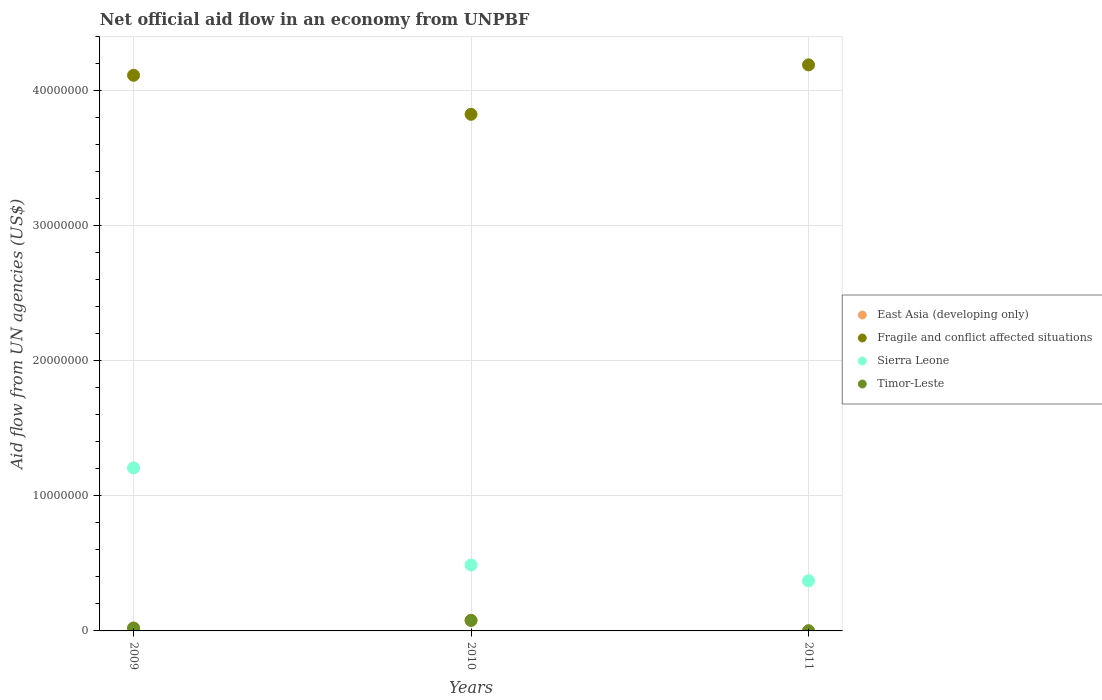How many different coloured dotlines are there?
Your answer should be compact. 4. Is the number of dotlines equal to the number of legend labels?
Give a very brief answer. Yes. What is the net official aid flow in Fragile and conflict affected situations in 2010?
Provide a short and direct response. 3.82e+07. Across all years, what is the maximum net official aid flow in Fragile and conflict affected situations?
Keep it short and to the point. 4.19e+07. Across all years, what is the minimum net official aid flow in Timor-Leste?
Offer a very short reply. 10000. In which year was the net official aid flow in East Asia (developing only) minimum?
Your answer should be compact. 2011. What is the total net official aid flow in Timor-Leste in the graph?
Keep it short and to the point. 1.00e+06. What is the difference between the net official aid flow in East Asia (developing only) in 2010 and that in 2011?
Give a very brief answer. 7.70e+05. What is the difference between the net official aid flow in East Asia (developing only) in 2011 and the net official aid flow in Sierra Leone in 2009?
Ensure brevity in your answer.  -1.21e+07. What is the average net official aid flow in Timor-Leste per year?
Ensure brevity in your answer.  3.33e+05. In the year 2011, what is the difference between the net official aid flow in Fragile and conflict affected situations and net official aid flow in East Asia (developing only)?
Offer a terse response. 4.19e+07. In how many years, is the net official aid flow in Fragile and conflict affected situations greater than 4000000 US$?
Offer a terse response. 3. Is the net official aid flow in Timor-Leste in 2009 less than that in 2011?
Offer a very short reply. No. What is the difference between the highest and the second highest net official aid flow in Sierra Leone?
Provide a short and direct response. 7.19e+06. What is the difference between the highest and the lowest net official aid flow in Sierra Leone?
Your answer should be compact. 8.36e+06. In how many years, is the net official aid flow in Fragile and conflict affected situations greater than the average net official aid flow in Fragile and conflict affected situations taken over all years?
Make the answer very short. 2. Is it the case that in every year, the sum of the net official aid flow in Timor-Leste and net official aid flow in Sierra Leone  is greater than the sum of net official aid flow in East Asia (developing only) and net official aid flow in Fragile and conflict affected situations?
Make the answer very short. Yes. Does the net official aid flow in Sierra Leone monotonically increase over the years?
Offer a very short reply. No. Is the net official aid flow in Timor-Leste strictly less than the net official aid flow in East Asia (developing only) over the years?
Provide a succinct answer. No. How many dotlines are there?
Make the answer very short. 4. How many years are there in the graph?
Provide a succinct answer. 3. Are the values on the major ticks of Y-axis written in scientific E-notation?
Your answer should be compact. No. Does the graph contain any zero values?
Give a very brief answer. No. Where does the legend appear in the graph?
Your response must be concise. Center right. What is the title of the graph?
Give a very brief answer. Net official aid flow in an economy from UNPBF. Does "Maldives" appear as one of the legend labels in the graph?
Provide a short and direct response. No. What is the label or title of the X-axis?
Give a very brief answer. Years. What is the label or title of the Y-axis?
Ensure brevity in your answer.  Aid flow from UN agencies (US$). What is the Aid flow from UN agencies (US$) of East Asia (developing only) in 2009?
Your answer should be very brief. 2.10e+05. What is the Aid flow from UN agencies (US$) of Fragile and conflict affected situations in 2009?
Give a very brief answer. 4.11e+07. What is the Aid flow from UN agencies (US$) of Sierra Leone in 2009?
Keep it short and to the point. 1.21e+07. What is the Aid flow from UN agencies (US$) of East Asia (developing only) in 2010?
Offer a terse response. 7.80e+05. What is the Aid flow from UN agencies (US$) in Fragile and conflict affected situations in 2010?
Provide a succinct answer. 3.82e+07. What is the Aid flow from UN agencies (US$) in Sierra Leone in 2010?
Offer a terse response. 4.88e+06. What is the Aid flow from UN agencies (US$) of Timor-Leste in 2010?
Offer a very short reply. 7.80e+05. What is the Aid flow from UN agencies (US$) in East Asia (developing only) in 2011?
Keep it short and to the point. 10000. What is the Aid flow from UN agencies (US$) in Fragile and conflict affected situations in 2011?
Offer a very short reply. 4.19e+07. What is the Aid flow from UN agencies (US$) in Sierra Leone in 2011?
Provide a short and direct response. 3.71e+06. Across all years, what is the maximum Aid flow from UN agencies (US$) in East Asia (developing only)?
Make the answer very short. 7.80e+05. Across all years, what is the maximum Aid flow from UN agencies (US$) in Fragile and conflict affected situations?
Provide a succinct answer. 4.19e+07. Across all years, what is the maximum Aid flow from UN agencies (US$) of Sierra Leone?
Ensure brevity in your answer.  1.21e+07. Across all years, what is the maximum Aid flow from UN agencies (US$) in Timor-Leste?
Make the answer very short. 7.80e+05. Across all years, what is the minimum Aid flow from UN agencies (US$) of Fragile and conflict affected situations?
Ensure brevity in your answer.  3.82e+07. Across all years, what is the minimum Aid flow from UN agencies (US$) of Sierra Leone?
Your response must be concise. 3.71e+06. Across all years, what is the minimum Aid flow from UN agencies (US$) of Timor-Leste?
Offer a very short reply. 10000. What is the total Aid flow from UN agencies (US$) of East Asia (developing only) in the graph?
Provide a succinct answer. 1.00e+06. What is the total Aid flow from UN agencies (US$) in Fragile and conflict affected situations in the graph?
Keep it short and to the point. 1.21e+08. What is the total Aid flow from UN agencies (US$) of Sierra Leone in the graph?
Ensure brevity in your answer.  2.07e+07. What is the total Aid flow from UN agencies (US$) of Timor-Leste in the graph?
Offer a terse response. 1.00e+06. What is the difference between the Aid flow from UN agencies (US$) of East Asia (developing only) in 2009 and that in 2010?
Give a very brief answer. -5.70e+05. What is the difference between the Aid flow from UN agencies (US$) in Fragile and conflict affected situations in 2009 and that in 2010?
Your answer should be very brief. 2.89e+06. What is the difference between the Aid flow from UN agencies (US$) of Sierra Leone in 2009 and that in 2010?
Your response must be concise. 7.19e+06. What is the difference between the Aid flow from UN agencies (US$) of Timor-Leste in 2009 and that in 2010?
Offer a terse response. -5.70e+05. What is the difference between the Aid flow from UN agencies (US$) in Fragile and conflict affected situations in 2009 and that in 2011?
Make the answer very short. -7.70e+05. What is the difference between the Aid flow from UN agencies (US$) in Sierra Leone in 2009 and that in 2011?
Ensure brevity in your answer.  8.36e+06. What is the difference between the Aid flow from UN agencies (US$) in Timor-Leste in 2009 and that in 2011?
Provide a short and direct response. 2.00e+05. What is the difference between the Aid flow from UN agencies (US$) in East Asia (developing only) in 2010 and that in 2011?
Make the answer very short. 7.70e+05. What is the difference between the Aid flow from UN agencies (US$) in Fragile and conflict affected situations in 2010 and that in 2011?
Give a very brief answer. -3.66e+06. What is the difference between the Aid flow from UN agencies (US$) of Sierra Leone in 2010 and that in 2011?
Your response must be concise. 1.17e+06. What is the difference between the Aid flow from UN agencies (US$) of Timor-Leste in 2010 and that in 2011?
Ensure brevity in your answer.  7.70e+05. What is the difference between the Aid flow from UN agencies (US$) of East Asia (developing only) in 2009 and the Aid flow from UN agencies (US$) of Fragile and conflict affected situations in 2010?
Your answer should be compact. -3.80e+07. What is the difference between the Aid flow from UN agencies (US$) of East Asia (developing only) in 2009 and the Aid flow from UN agencies (US$) of Sierra Leone in 2010?
Your answer should be compact. -4.67e+06. What is the difference between the Aid flow from UN agencies (US$) in East Asia (developing only) in 2009 and the Aid flow from UN agencies (US$) in Timor-Leste in 2010?
Give a very brief answer. -5.70e+05. What is the difference between the Aid flow from UN agencies (US$) of Fragile and conflict affected situations in 2009 and the Aid flow from UN agencies (US$) of Sierra Leone in 2010?
Offer a very short reply. 3.63e+07. What is the difference between the Aid flow from UN agencies (US$) in Fragile and conflict affected situations in 2009 and the Aid flow from UN agencies (US$) in Timor-Leste in 2010?
Provide a succinct answer. 4.04e+07. What is the difference between the Aid flow from UN agencies (US$) of Sierra Leone in 2009 and the Aid flow from UN agencies (US$) of Timor-Leste in 2010?
Keep it short and to the point. 1.13e+07. What is the difference between the Aid flow from UN agencies (US$) in East Asia (developing only) in 2009 and the Aid flow from UN agencies (US$) in Fragile and conflict affected situations in 2011?
Offer a very short reply. -4.17e+07. What is the difference between the Aid flow from UN agencies (US$) of East Asia (developing only) in 2009 and the Aid flow from UN agencies (US$) of Sierra Leone in 2011?
Make the answer very short. -3.50e+06. What is the difference between the Aid flow from UN agencies (US$) in Fragile and conflict affected situations in 2009 and the Aid flow from UN agencies (US$) in Sierra Leone in 2011?
Give a very brief answer. 3.74e+07. What is the difference between the Aid flow from UN agencies (US$) in Fragile and conflict affected situations in 2009 and the Aid flow from UN agencies (US$) in Timor-Leste in 2011?
Provide a short and direct response. 4.11e+07. What is the difference between the Aid flow from UN agencies (US$) of Sierra Leone in 2009 and the Aid flow from UN agencies (US$) of Timor-Leste in 2011?
Your answer should be very brief. 1.21e+07. What is the difference between the Aid flow from UN agencies (US$) in East Asia (developing only) in 2010 and the Aid flow from UN agencies (US$) in Fragile and conflict affected situations in 2011?
Provide a short and direct response. -4.11e+07. What is the difference between the Aid flow from UN agencies (US$) in East Asia (developing only) in 2010 and the Aid flow from UN agencies (US$) in Sierra Leone in 2011?
Your answer should be very brief. -2.93e+06. What is the difference between the Aid flow from UN agencies (US$) in East Asia (developing only) in 2010 and the Aid flow from UN agencies (US$) in Timor-Leste in 2011?
Provide a short and direct response. 7.70e+05. What is the difference between the Aid flow from UN agencies (US$) in Fragile and conflict affected situations in 2010 and the Aid flow from UN agencies (US$) in Sierra Leone in 2011?
Your answer should be compact. 3.45e+07. What is the difference between the Aid flow from UN agencies (US$) in Fragile and conflict affected situations in 2010 and the Aid flow from UN agencies (US$) in Timor-Leste in 2011?
Ensure brevity in your answer.  3.82e+07. What is the difference between the Aid flow from UN agencies (US$) in Sierra Leone in 2010 and the Aid flow from UN agencies (US$) in Timor-Leste in 2011?
Give a very brief answer. 4.87e+06. What is the average Aid flow from UN agencies (US$) of East Asia (developing only) per year?
Offer a terse response. 3.33e+05. What is the average Aid flow from UN agencies (US$) of Fragile and conflict affected situations per year?
Provide a short and direct response. 4.04e+07. What is the average Aid flow from UN agencies (US$) in Sierra Leone per year?
Keep it short and to the point. 6.89e+06. What is the average Aid flow from UN agencies (US$) of Timor-Leste per year?
Your answer should be compact. 3.33e+05. In the year 2009, what is the difference between the Aid flow from UN agencies (US$) in East Asia (developing only) and Aid flow from UN agencies (US$) in Fragile and conflict affected situations?
Ensure brevity in your answer.  -4.09e+07. In the year 2009, what is the difference between the Aid flow from UN agencies (US$) in East Asia (developing only) and Aid flow from UN agencies (US$) in Sierra Leone?
Your answer should be very brief. -1.19e+07. In the year 2009, what is the difference between the Aid flow from UN agencies (US$) of Fragile and conflict affected situations and Aid flow from UN agencies (US$) of Sierra Leone?
Your answer should be compact. 2.91e+07. In the year 2009, what is the difference between the Aid flow from UN agencies (US$) in Fragile and conflict affected situations and Aid flow from UN agencies (US$) in Timor-Leste?
Provide a short and direct response. 4.09e+07. In the year 2009, what is the difference between the Aid flow from UN agencies (US$) in Sierra Leone and Aid flow from UN agencies (US$) in Timor-Leste?
Provide a short and direct response. 1.19e+07. In the year 2010, what is the difference between the Aid flow from UN agencies (US$) of East Asia (developing only) and Aid flow from UN agencies (US$) of Fragile and conflict affected situations?
Offer a very short reply. -3.75e+07. In the year 2010, what is the difference between the Aid flow from UN agencies (US$) of East Asia (developing only) and Aid flow from UN agencies (US$) of Sierra Leone?
Your response must be concise. -4.10e+06. In the year 2010, what is the difference between the Aid flow from UN agencies (US$) in Fragile and conflict affected situations and Aid flow from UN agencies (US$) in Sierra Leone?
Your answer should be very brief. 3.34e+07. In the year 2010, what is the difference between the Aid flow from UN agencies (US$) of Fragile and conflict affected situations and Aid flow from UN agencies (US$) of Timor-Leste?
Ensure brevity in your answer.  3.75e+07. In the year 2010, what is the difference between the Aid flow from UN agencies (US$) in Sierra Leone and Aid flow from UN agencies (US$) in Timor-Leste?
Offer a terse response. 4.10e+06. In the year 2011, what is the difference between the Aid flow from UN agencies (US$) in East Asia (developing only) and Aid flow from UN agencies (US$) in Fragile and conflict affected situations?
Give a very brief answer. -4.19e+07. In the year 2011, what is the difference between the Aid flow from UN agencies (US$) in East Asia (developing only) and Aid flow from UN agencies (US$) in Sierra Leone?
Offer a very short reply. -3.70e+06. In the year 2011, what is the difference between the Aid flow from UN agencies (US$) in Fragile and conflict affected situations and Aid flow from UN agencies (US$) in Sierra Leone?
Give a very brief answer. 3.82e+07. In the year 2011, what is the difference between the Aid flow from UN agencies (US$) in Fragile and conflict affected situations and Aid flow from UN agencies (US$) in Timor-Leste?
Provide a succinct answer. 4.19e+07. In the year 2011, what is the difference between the Aid flow from UN agencies (US$) in Sierra Leone and Aid flow from UN agencies (US$) in Timor-Leste?
Your answer should be compact. 3.70e+06. What is the ratio of the Aid flow from UN agencies (US$) of East Asia (developing only) in 2009 to that in 2010?
Keep it short and to the point. 0.27. What is the ratio of the Aid flow from UN agencies (US$) of Fragile and conflict affected situations in 2009 to that in 2010?
Make the answer very short. 1.08. What is the ratio of the Aid flow from UN agencies (US$) in Sierra Leone in 2009 to that in 2010?
Give a very brief answer. 2.47. What is the ratio of the Aid flow from UN agencies (US$) in Timor-Leste in 2009 to that in 2010?
Make the answer very short. 0.27. What is the ratio of the Aid flow from UN agencies (US$) of Fragile and conflict affected situations in 2009 to that in 2011?
Your answer should be compact. 0.98. What is the ratio of the Aid flow from UN agencies (US$) in Sierra Leone in 2009 to that in 2011?
Give a very brief answer. 3.25. What is the ratio of the Aid flow from UN agencies (US$) of East Asia (developing only) in 2010 to that in 2011?
Provide a short and direct response. 78. What is the ratio of the Aid flow from UN agencies (US$) of Fragile and conflict affected situations in 2010 to that in 2011?
Your answer should be very brief. 0.91. What is the ratio of the Aid flow from UN agencies (US$) of Sierra Leone in 2010 to that in 2011?
Ensure brevity in your answer.  1.32. What is the difference between the highest and the second highest Aid flow from UN agencies (US$) in East Asia (developing only)?
Ensure brevity in your answer.  5.70e+05. What is the difference between the highest and the second highest Aid flow from UN agencies (US$) in Fragile and conflict affected situations?
Offer a very short reply. 7.70e+05. What is the difference between the highest and the second highest Aid flow from UN agencies (US$) of Sierra Leone?
Offer a terse response. 7.19e+06. What is the difference between the highest and the second highest Aid flow from UN agencies (US$) in Timor-Leste?
Ensure brevity in your answer.  5.70e+05. What is the difference between the highest and the lowest Aid flow from UN agencies (US$) in East Asia (developing only)?
Your answer should be very brief. 7.70e+05. What is the difference between the highest and the lowest Aid flow from UN agencies (US$) of Fragile and conflict affected situations?
Offer a terse response. 3.66e+06. What is the difference between the highest and the lowest Aid flow from UN agencies (US$) in Sierra Leone?
Your response must be concise. 8.36e+06. What is the difference between the highest and the lowest Aid flow from UN agencies (US$) in Timor-Leste?
Your response must be concise. 7.70e+05. 